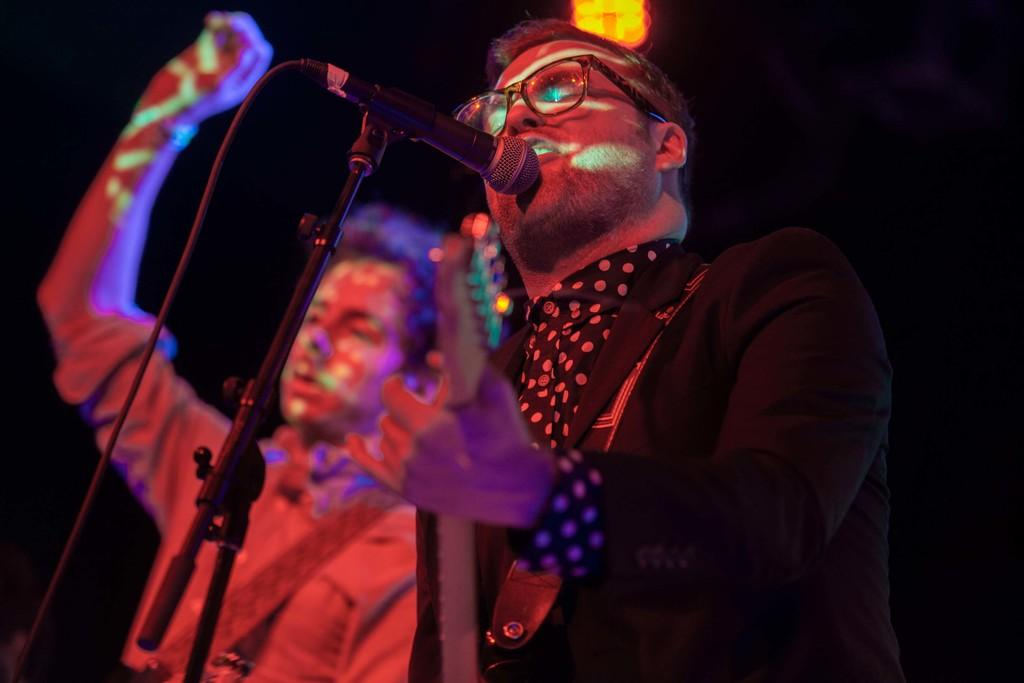What is the man in the image doing? The man in the image is singing and playing guitar. What is the man wearing? The man is wearing a black suit. Is there another person in the image? Yes, there is another man wearing a guitar in the image. What type of event might the image be taken at? The image appears to be taken at a concert. What book is the man reading while playing the guitar in the image? There is no book present in the image; the man is singing and playing guitar. 